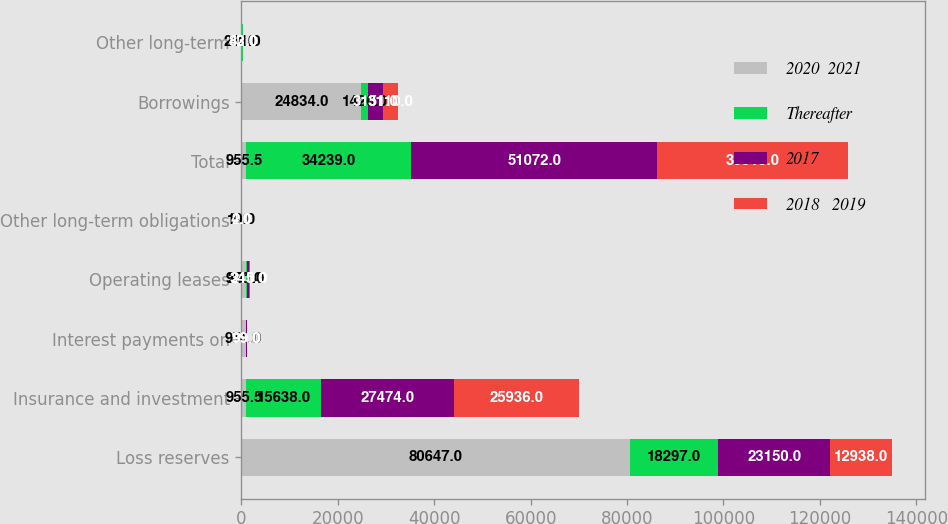<chart> <loc_0><loc_0><loc_500><loc_500><stacked_bar_chart><ecel><fcel>Loss reserves<fcel>Insurance and investment<fcel>Interest payments on<fcel>Operating leases<fcel>Other long-term obligations<fcel>Total<fcel>Borrowings<fcel>Other long-term<nl><fcel>2020  2021<fcel>80647<fcel>955.5<fcel>951<fcel>960<fcel>10<fcel>955.5<fcel>24834<fcel>211<nl><fcel>Thereafter<fcel>18297<fcel>15638<fcel>50<fcel>251<fcel>3<fcel>34239<fcel>1426<fcel>41<nl><fcel>2017<fcel>23150<fcel>27474<fcel>99<fcel>345<fcel>4<fcel>51072<fcel>3151<fcel>82<nl><fcel>2018   2019<fcel>12938<fcel>25936<fcel>99<fcel>210<fcel>2<fcel>39515<fcel>3110<fcel>43<nl></chart> 